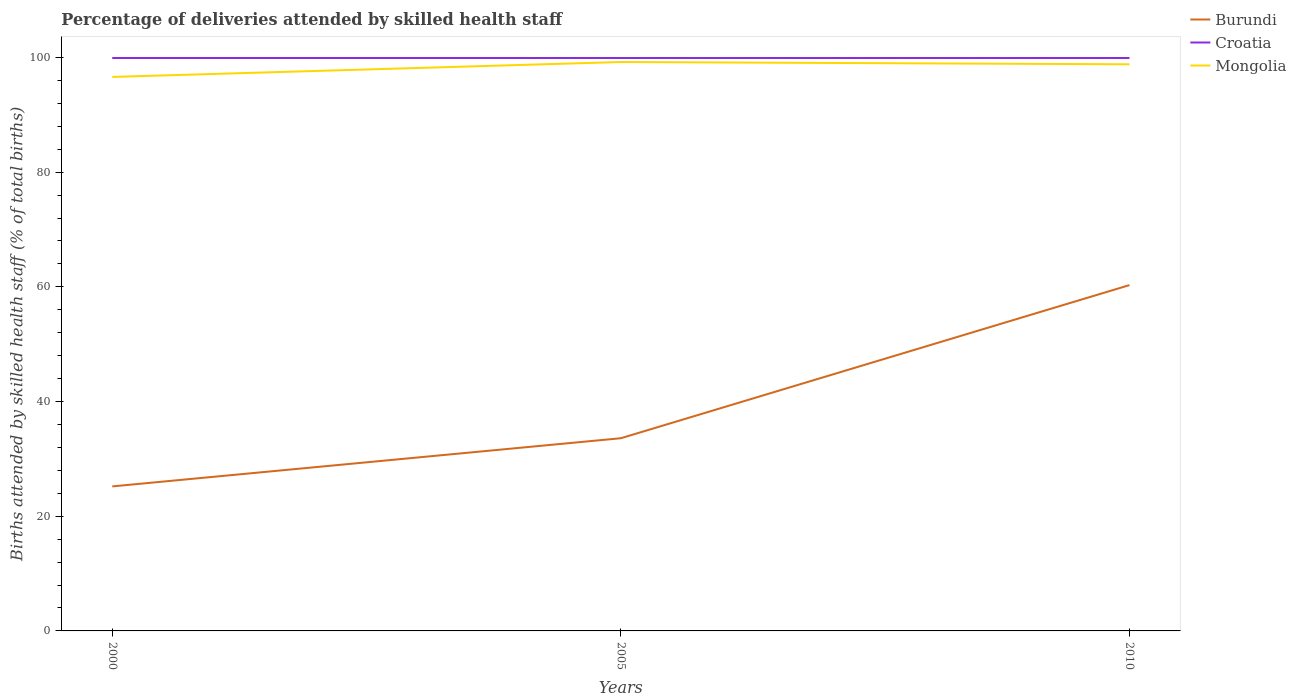How many different coloured lines are there?
Offer a terse response. 3. Is the number of lines equal to the number of legend labels?
Make the answer very short. Yes. Across all years, what is the maximum percentage of births attended by skilled health staff in Burundi?
Offer a terse response. 25.2. In which year was the percentage of births attended by skilled health staff in Croatia maximum?
Make the answer very short. 2000. What is the total percentage of births attended by skilled health staff in Burundi in the graph?
Ensure brevity in your answer.  -26.7. What is the difference between the highest and the second highest percentage of births attended by skilled health staff in Mongolia?
Provide a short and direct response. 2.6. What is the difference between the highest and the lowest percentage of births attended by skilled health staff in Croatia?
Your response must be concise. 0. Is the percentage of births attended by skilled health staff in Burundi strictly greater than the percentage of births attended by skilled health staff in Mongolia over the years?
Offer a terse response. Yes. How many lines are there?
Your answer should be compact. 3. How many years are there in the graph?
Your answer should be compact. 3. What is the difference between two consecutive major ticks on the Y-axis?
Your response must be concise. 20. Are the values on the major ticks of Y-axis written in scientific E-notation?
Provide a short and direct response. No. Does the graph contain any zero values?
Offer a terse response. No. Does the graph contain grids?
Keep it short and to the point. No. Where does the legend appear in the graph?
Make the answer very short. Top right. How are the legend labels stacked?
Keep it short and to the point. Vertical. What is the title of the graph?
Provide a short and direct response. Percentage of deliveries attended by skilled health staff. What is the label or title of the X-axis?
Provide a succinct answer. Years. What is the label or title of the Y-axis?
Keep it short and to the point. Births attended by skilled health staff (% of total births). What is the Births attended by skilled health staff (% of total births) in Burundi in 2000?
Provide a succinct answer. 25.2. What is the Births attended by skilled health staff (% of total births) of Croatia in 2000?
Your answer should be very brief. 99.9. What is the Births attended by skilled health staff (% of total births) of Mongolia in 2000?
Ensure brevity in your answer.  96.6. What is the Births attended by skilled health staff (% of total births) of Burundi in 2005?
Your response must be concise. 33.6. What is the Births attended by skilled health staff (% of total births) in Croatia in 2005?
Your answer should be compact. 99.9. What is the Births attended by skilled health staff (% of total births) of Mongolia in 2005?
Your answer should be compact. 99.2. What is the Births attended by skilled health staff (% of total births) of Burundi in 2010?
Your answer should be compact. 60.3. What is the Births attended by skilled health staff (% of total births) of Croatia in 2010?
Keep it short and to the point. 99.9. What is the Births attended by skilled health staff (% of total births) of Mongolia in 2010?
Ensure brevity in your answer.  98.8. Across all years, what is the maximum Births attended by skilled health staff (% of total births) of Burundi?
Your answer should be very brief. 60.3. Across all years, what is the maximum Births attended by skilled health staff (% of total births) of Croatia?
Provide a short and direct response. 99.9. Across all years, what is the maximum Births attended by skilled health staff (% of total births) in Mongolia?
Ensure brevity in your answer.  99.2. Across all years, what is the minimum Births attended by skilled health staff (% of total births) in Burundi?
Keep it short and to the point. 25.2. Across all years, what is the minimum Births attended by skilled health staff (% of total births) of Croatia?
Your response must be concise. 99.9. Across all years, what is the minimum Births attended by skilled health staff (% of total births) of Mongolia?
Provide a succinct answer. 96.6. What is the total Births attended by skilled health staff (% of total births) in Burundi in the graph?
Your answer should be compact. 119.1. What is the total Births attended by skilled health staff (% of total births) of Croatia in the graph?
Offer a terse response. 299.7. What is the total Births attended by skilled health staff (% of total births) of Mongolia in the graph?
Provide a succinct answer. 294.6. What is the difference between the Births attended by skilled health staff (% of total births) in Burundi in 2000 and that in 2005?
Offer a terse response. -8.4. What is the difference between the Births attended by skilled health staff (% of total births) of Croatia in 2000 and that in 2005?
Provide a succinct answer. 0. What is the difference between the Births attended by skilled health staff (% of total births) in Mongolia in 2000 and that in 2005?
Give a very brief answer. -2.6. What is the difference between the Births attended by skilled health staff (% of total births) in Burundi in 2000 and that in 2010?
Ensure brevity in your answer.  -35.1. What is the difference between the Births attended by skilled health staff (% of total births) of Mongolia in 2000 and that in 2010?
Keep it short and to the point. -2.2. What is the difference between the Births attended by skilled health staff (% of total births) of Burundi in 2005 and that in 2010?
Provide a succinct answer. -26.7. What is the difference between the Births attended by skilled health staff (% of total births) of Croatia in 2005 and that in 2010?
Provide a succinct answer. 0. What is the difference between the Births attended by skilled health staff (% of total births) in Burundi in 2000 and the Births attended by skilled health staff (% of total births) in Croatia in 2005?
Offer a very short reply. -74.7. What is the difference between the Births attended by skilled health staff (% of total births) in Burundi in 2000 and the Births attended by skilled health staff (% of total births) in Mongolia in 2005?
Offer a terse response. -74. What is the difference between the Births attended by skilled health staff (% of total births) of Croatia in 2000 and the Births attended by skilled health staff (% of total births) of Mongolia in 2005?
Offer a very short reply. 0.7. What is the difference between the Births attended by skilled health staff (% of total births) in Burundi in 2000 and the Births attended by skilled health staff (% of total births) in Croatia in 2010?
Your answer should be very brief. -74.7. What is the difference between the Births attended by skilled health staff (% of total births) of Burundi in 2000 and the Births attended by skilled health staff (% of total births) of Mongolia in 2010?
Offer a very short reply. -73.6. What is the difference between the Births attended by skilled health staff (% of total births) in Croatia in 2000 and the Births attended by skilled health staff (% of total births) in Mongolia in 2010?
Provide a short and direct response. 1.1. What is the difference between the Births attended by skilled health staff (% of total births) of Burundi in 2005 and the Births attended by skilled health staff (% of total births) of Croatia in 2010?
Offer a very short reply. -66.3. What is the difference between the Births attended by skilled health staff (% of total births) of Burundi in 2005 and the Births attended by skilled health staff (% of total births) of Mongolia in 2010?
Make the answer very short. -65.2. What is the average Births attended by skilled health staff (% of total births) in Burundi per year?
Provide a succinct answer. 39.7. What is the average Births attended by skilled health staff (% of total births) in Croatia per year?
Your response must be concise. 99.9. What is the average Births attended by skilled health staff (% of total births) of Mongolia per year?
Offer a very short reply. 98.2. In the year 2000, what is the difference between the Births attended by skilled health staff (% of total births) of Burundi and Births attended by skilled health staff (% of total births) of Croatia?
Your answer should be compact. -74.7. In the year 2000, what is the difference between the Births attended by skilled health staff (% of total births) of Burundi and Births attended by skilled health staff (% of total births) of Mongolia?
Make the answer very short. -71.4. In the year 2000, what is the difference between the Births attended by skilled health staff (% of total births) of Croatia and Births attended by skilled health staff (% of total births) of Mongolia?
Your response must be concise. 3.3. In the year 2005, what is the difference between the Births attended by skilled health staff (% of total births) of Burundi and Births attended by skilled health staff (% of total births) of Croatia?
Offer a very short reply. -66.3. In the year 2005, what is the difference between the Births attended by skilled health staff (% of total births) of Burundi and Births attended by skilled health staff (% of total births) of Mongolia?
Your answer should be very brief. -65.6. In the year 2005, what is the difference between the Births attended by skilled health staff (% of total births) of Croatia and Births attended by skilled health staff (% of total births) of Mongolia?
Provide a short and direct response. 0.7. In the year 2010, what is the difference between the Births attended by skilled health staff (% of total births) of Burundi and Births attended by skilled health staff (% of total births) of Croatia?
Offer a terse response. -39.6. In the year 2010, what is the difference between the Births attended by skilled health staff (% of total births) of Burundi and Births attended by skilled health staff (% of total births) of Mongolia?
Provide a succinct answer. -38.5. What is the ratio of the Births attended by skilled health staff (% of total births) of Croatia in 2000 to that in 2005?
Provide a short and direct response. 1. What is the ratio of the Births attended by skilled health staff (% of total births) in Mongolia in 2000 to that in 2005?
Provide a succinct answer. 0.97. What is the ratio of the Births attended by skilled health staff (% of total births) of Burundi in 2000 to that in 2010?
Your answer should be very brief. 0.42. What is the ratio of the Births attended by skilled health staff (% of total births) in Mongolia in 2000 to that in 2010?
Offer a terse response. 0.98. What is the ratio of the Births attended by skilled health staff (% of total births) of Burundi in 2005 to that in 2010?
Offer a very short reply. 0.56. What is the ratio of the Births attended by skilled health staff (% of total births) in Mongolia in 2005 to that in 2010?
Make the answer very short. 1. What is the difference between the highest and the second highest Births attended by skilled health staff (% of total births) of Burundi?
Provide a short and direct response. 26.7. What is the difference between the highest and the lowest Births attended by skilled health staff (% of total births) in Burundi?
Give a very brief answer. 35.1. What is the difference between the highest and the lowest Births attended by skilled health staff (% of total births) of Mongolia?
Provide a succinct answer. 2.6. 